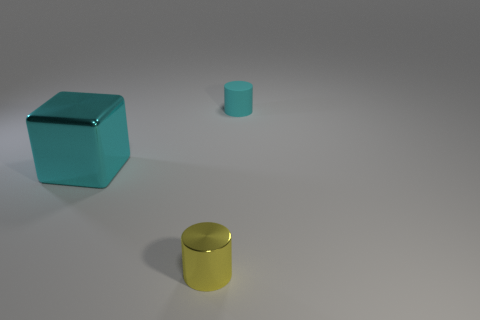Add 1 large shiny cylinders. How many objects exist? 4 Subtract all cyan cylinders. How many cylinders are left? 1 Subtract all gray cylinders. Subtract all blue cubes. How many cylinders are left? 2 Subtract all blocks. How many objects are left? 2 Subtract 0 yellow cubes. How many objects are left? 3 Subtract all purple spheres. Subtract all big cyan metallic objects. How many objects are left? 2 Add 3 matte cylinders. How many matte cylinders are left? 4 Add 1 large things. How many large things exist? 2 